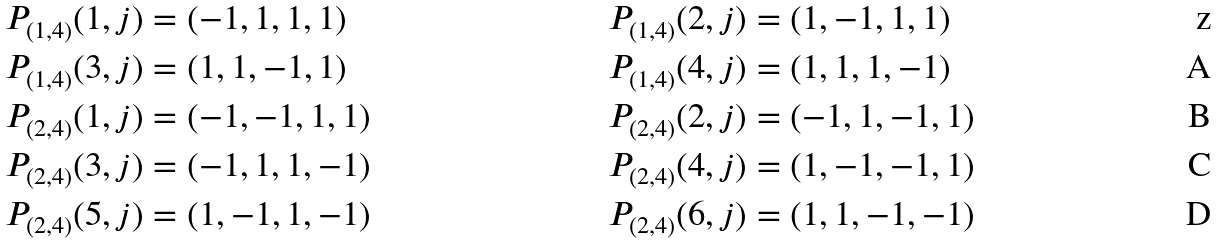<formula> <loc_0><loc_0><loc_500><loc_500>P _ { ( 1 , 4 ) } ( 1 , j ) & = ( - 1 , 1 , 1 , 1 ) & P _ { ( 1 , 4 ) } ( 2 , j ) & = ( 1 , - 1 , 1 , 1 ) \\ P _ { ( 1 , 4 ) } ( 3 , j ) & = ( 1 , 1 , - 1 , 1 ) & P _ { ( 1 , 4 ) } ( 4 , j ) & = ( 1 , 1 , 1 , - 1 ) \\ P _ { ( 2 , 4 ) } ( 1 , j ) & = ( - 1 , - 1 , 1 , 1 ) & P _ { ( 2 , 4 ) } ( 2 , j ) & = ( - 1 , 1 , - 1 , 1 ) \\ P _ { ( 2 , 4 ) } ( 3 , j ) & = ( - 1 , 1 , 1 , - 1 ) & P _ { ( 2 , 4 ) } ( 4 , j ) & = ( 1 , - 1 , - 1 , 1 ) \\ P _ { ( 2 , 4 ) } ( 5 , j ) & = ( 1 , - 1 , 1 , - 1 ) & P _ { ( 2 , 4 ) } ( 6 , j ) & = ( 1 , 1 , - 1 , - 1 )</formula> 